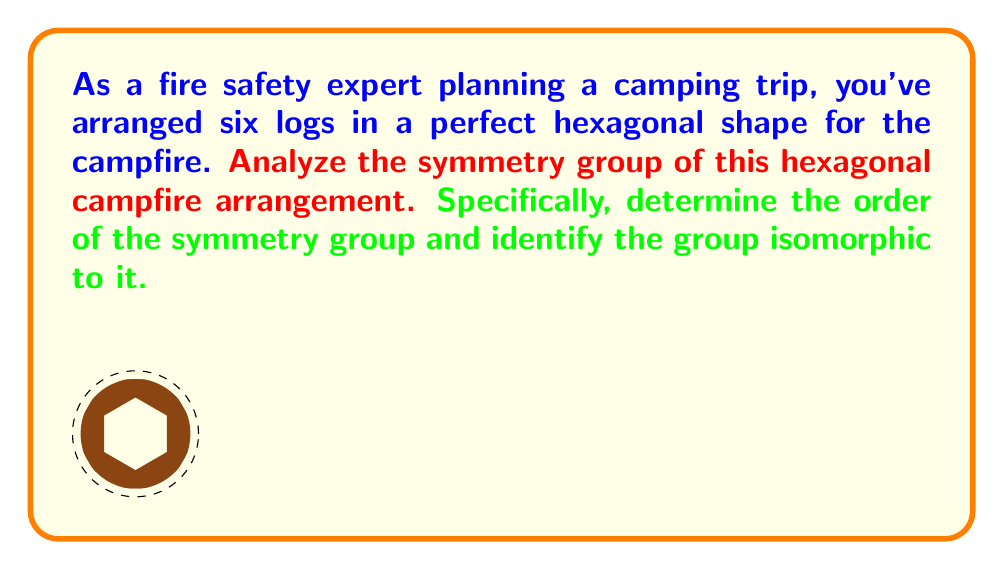Provide a solution to this math problem. To analyze the symmetry group of the hexagonal campfire arrangement, we need to consider all the symmetries that leave the arrangement unchanged. These include rotations and reflections.

1. Rotational symmetries:
   - The hexagon has 6-fold rotational symmetry, meaning it can be rotated by multiples of 60° (or $\frac{\pi}{3}$ radians) and remain unchanged.
   - There are 6 distinct rotations: 0°, 60°, 120°, 180°, 240°, and 300°.

2. Reflection symmetries:
   - The hexagon has 6 lines of reflection symmetry: 3 passing through opposite vertices and 3 passing through the midpoints of opposite sides.

3. Total number of symmetries:
   - The identity operation (0° rotation) is counted among the rotations.
   - Total symmetries = 6 rotations + 6 reflections = 12

The symmetry group of the hexagon is known as the dihedral group of order 12, denoted as $D_6$ or $D_{12}$ (depending on the notation convention).

To identify the group isomorphic to this symmetry group, we note that:
- It has 12 elements
- It is non-abelian (rotations followed by reflections are not commutative)
- It contains both rotations and reflections

These properties uniquely identify the dihedral group $D_6$ (or $D_{12}$).

The group can be generated by two elements:
1. $r$: a rotation by 60°
2. $s$: a reflection across a line of symmetry

With the relations:
$$r^6 = e$$ (where $e$ is the identity element)
$$s^2 = e$$
$$srs = r^{-1}$$

These relations fully define the group structure.
Answer: The symmetry group of the hexagonal campfire arrangement has order 12 and is isomorphic to the dihedral group $D_6$ (or $D_{12}$). 